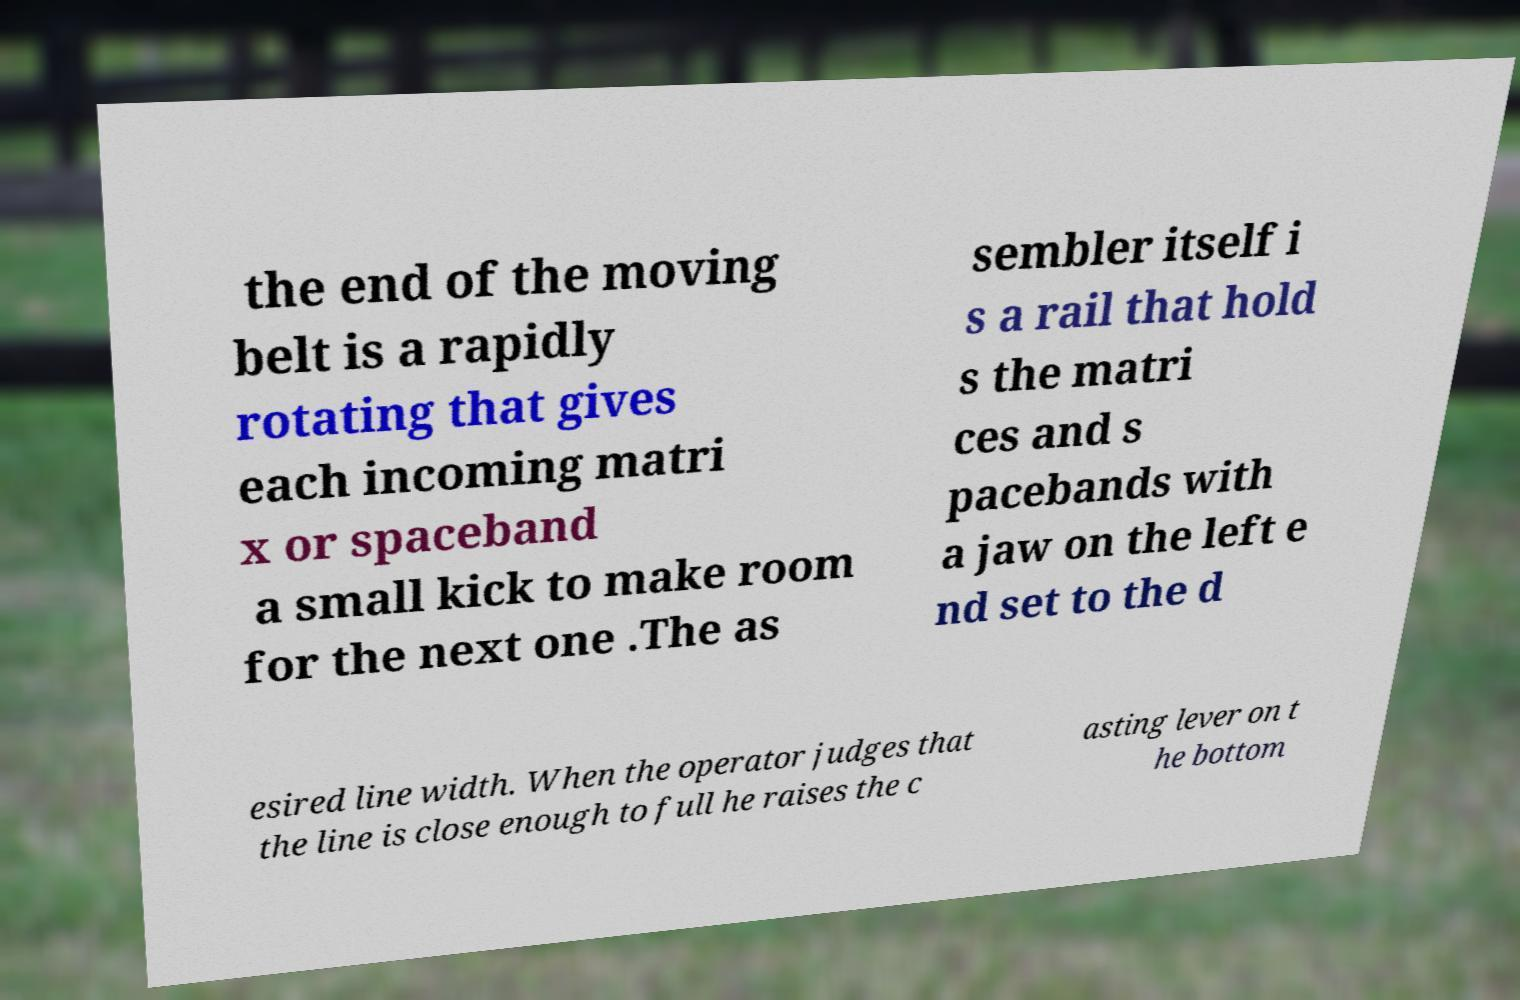Can you read and provide the text displayed in the image?This photo seems to have some interesting text. Can you extract and type it out for me? the end of the moving belt is a rapidly rotating that gives each incoming matri x or spaceband a small kick to make room for the next one .The as sembler itself i s a rail that hold s the matri ces and s pacebands with a jaw on the left e nd set to the d esired line width. When the operator judges that the line is close enough to full he raises the c asting lever on t he bottom 